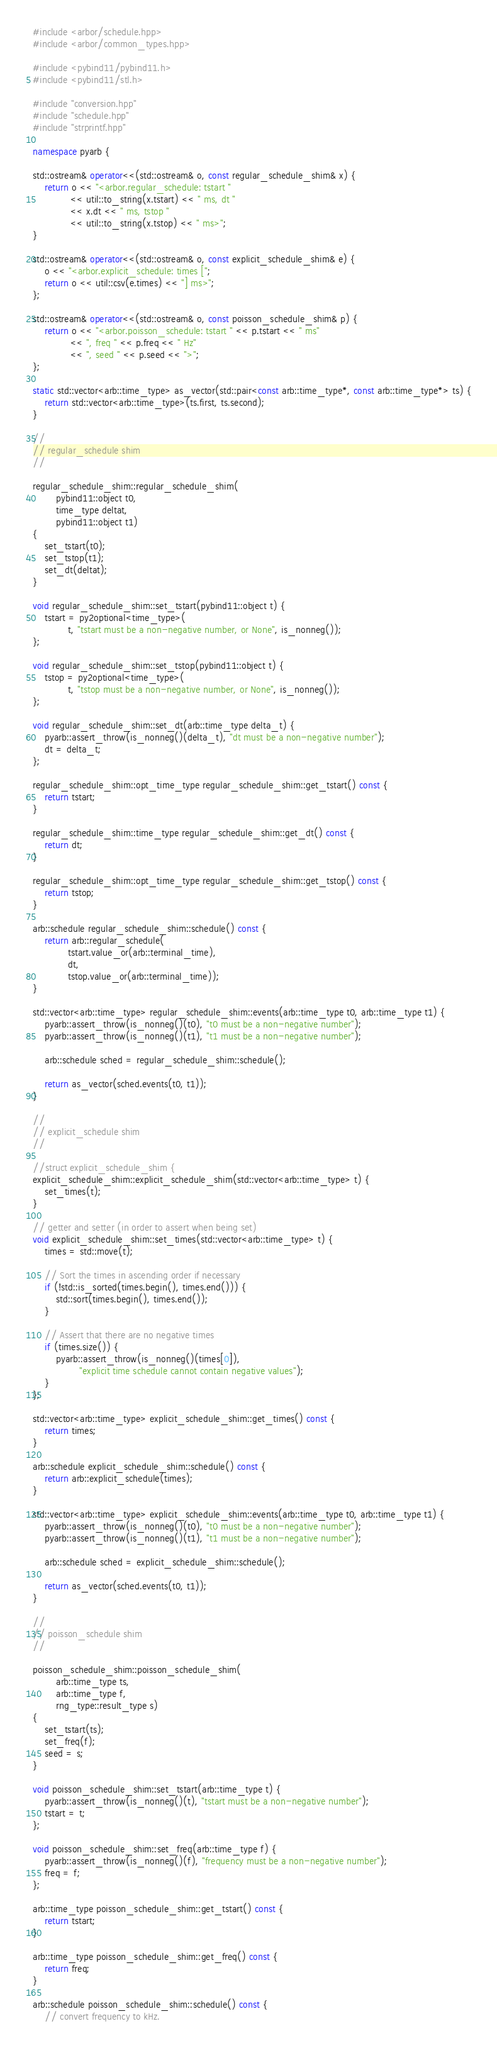<code> <loc_0><loc_0><loc_500><loc_500><_C++_>#include <arbor/schedule.hpp>
#include <arbor/common_types.hpp>

#include <pybind11/pybind11.h>
#include <pybind11/stl.h>

#include "conversion.hpp"
#include "schedule.hpp"
#include "strprintf.hpp"

namespace pyarb {

std::ostream& operator<<(std::ostream& o, const regular_schedule_shim& x) {
    return o << "<arbor.regular_schedule: tstart "
             << util::to_string(x.tstart) << " ms, dt "
             << x.dt << " ms, tstop "
             << util::to_string(x.tstop) << " ms>";
}

std::ostream& operator<<(std::ostream& o, const explicit_schedule_shim& e) {
    o << "<arbor.explicit_schedule: times [";
    return o << util::csv(e.times) << "] ms>";
};

std::ostream& operator<<(std::ostream& o, const poisson_schedule_shim& p) {
    return o << "<arbor.poisson_schedule: tstart " << p.tstart << " ms"
             << ", freq " << p.freq << " Hz"
             << ", seed " << p.seed << ">";
};

static std::vector<arb::time_type> as_vector(std::pair<const arb::time_type*, const arb::time_type*> ts) {
    return std::vector<arb::time_type>(ts.first, ts.second);
}

//
// regular_schedule shim
//

regular_schedule_shim::regular_schedule_shim(
        pybind11::object t0,
        time_type deltat,
        pybind11::object t1)
{
    set_tstart(t0);
    set_tstop(t1);
    set_dt(deltat);
}

void regular_schedule_shim::set_tstart(pybind11::object t) {
    tstart = py2optional<time_type>(
            t, "tstart must be a non-negative number, or None", is_nonneg());
};

void regular_schedule_shim::set_tstop(pybind11::object t) {
    tstop = py2optional<time_type>(
            t, "tstop must be a non-negative number, or None", is_nonneg());
};

void regular_schedule_shim::set_dt(arb::time_type delta_t) {
    pyarb::assert_throw(is_nonneg()(delta_t), "dt must be a non-negative number");
    dt = delta_t;
};

regular_schedule_shim::opt_time_type regular_schedule_shim::get_tstart() const {
    return tstart;
}

regular_schedule_shim::time_type regular_schedule_shim::get_dt() const {
    return dt;
}

regular_schedule_shim::opt_time_type regular_schedule_shim::get_tstop() const {
    return tstop;
}

arb::schedule regular_schedule_shim::schedule() const {
    return arb::regular_schedule(
            tstart.value_or(arb::terminal_time),
            dt,
            tstop.value_or(arb::terminal_time));
}

std::vector<arb::time_type> regular_schedule_shim::events(arb::time_type t0, arb::time_type t1) {
    pyarb::assert_throw(is_nonneg()(t0), "t0 must be a non-negative number");
    pyarb::assert_throw(is_nonneg()(t1), "t1 must be a non-negative number");

    arb::schedule sched = regular_schedule_shim::schedule();

    return as_vector(sched.events(t0, t1));
}

//
// explicit_schedule shim
//

//struct explicit_schedule_shim {
explicit_schedule_shim::explicit_schedule_shim(std::vector<arb::time_type> t) {
    set_times(t);
}

// getter and setter (in order to assert when being set)
void explicit_schedule_shim::set_times(std::vector<arb::time_type> t) {
    times = std::move(t);

    // Sort the times in ascending order if necessary
    if (!std::is_sorted(times.begin(), times.end())) {
        std::sort(times.begin(), times.end());
    }

    // Assert that there are no negative times
    if (times.size()) {
        pyarb::assert_throw(is_nonneg()(times[0]),
                "explicit time schedule cannot contain negative values");
    }
};

std::vector<arb::time_type> explicit_schedule_shim::get_times() const {
    return times;
}

arb::schedule explicit_schedule_shim::schedule() const {
    return arb::explicit_schedule(times);
}

std::vector<arb::time_type> explicit_schedule_shim::events(arb::time_type t0, arb::time_type t1) {
    pyarb::assert_throw(is_nonneg()(t0), "t0 must be a non-negative number");
    pyarb::assert_throw(is_nonneg()(t1), "t1 must be a non-negative number");

    arb::schedule sched = explicit_schedule_shim::schedule();

    return as_vector(sched.events(t0, t1));
}

//
// poisson_schedule shim
//

poisson_schedule_shim::poisson_schedule_shim(
        arb::time_type ts,
        arb::time_type f,
        rng_type::result_type s)
{
    set_tstart(ts);
    set_freq(f);
    seed = s;
}

void poisson_schedule_shim::set_tstart(arb::time_type t) {
    pyarb::assert_throw(is_nonneg()(t), "tstart must be a non-negative number");
    tstart = t;
};

void poisson_schedule_shim::set_freq(arb::time_type f) {
    pyarb::assert_throw(is_nonneg()(f), "frequency must be a non-negative number");
    freq = f;
};

arb::time_type poisson_schedule_shim::get_tstart() const {
    return tstart;
}

arb::time_type poisson_schedule_shim::get_freq() const {
    return freq;
}

arb::schedule poisson_schedule_shim::schedule() const {
    // convert frequency to kHz.</code> 